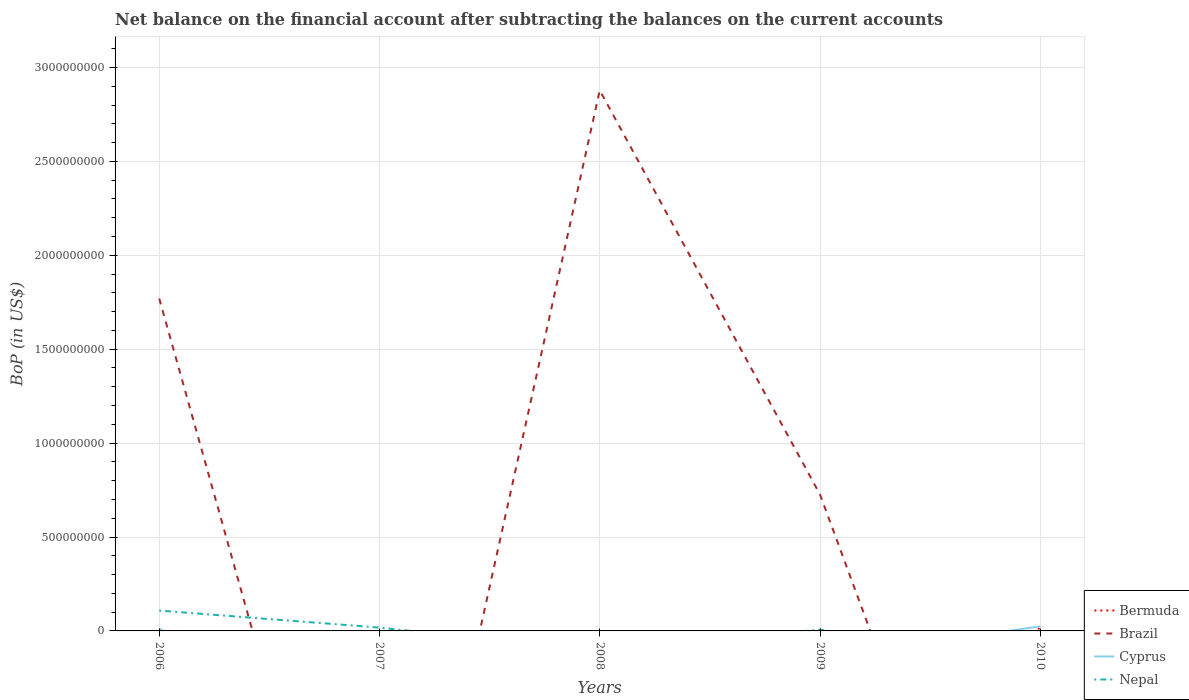Does the line corresponding to Bermuda intersect with the line corresponding to Nepal?
Your answer should be compact. Yes. Across all years, what is the maximum Balance of Payments in Nepal?
Keep it short and to the point. 0. What is the total Balance of Payments in Nepal in the graph?
Offer a terse response. 1.07e+07. What is the difference between the highest and the second highest Balance of Payments in Nepal?
Provide a succinct answer. 1.08e+08. How many lines are there?
Provide a succinct answer. 4. How many years are there in the graph?
Keep it short and to the point. 5. Are the values on the major ticks of Y-axis written in scientific E-notation?
Your answer should be very brief. No. Where does the legend appear in the graph?
Your answer should be very brief. Bottom right. How are the legend labels stacked?
Offer a very short reply. Vertical. What is the title of the graph?
Your answer should be very brief. Net balance on the financial account after subtracting the balances on the current accounts. Does "Kuwait" appear as one of the legend labels in the graph?
Your answer should be very brief. No. What is the label or title of the X-axis?
Your answer should be very brief. Years. What is the label or title of the Y-axis?
Offer a very short reply. BoP (in US$). What is the BoP (in US$) of Brazil in 2006?
Provide a short and direct response. 1.77e+09. What is the BoP (in US$) of Cyprus in 2006?
Offer a terse response. 1.33e+07. What is the BoP (in US$) in Nepal in 2006?
Give a very brief answer. 1.08e+08. What is the BoP (in US$) in Bermuda in 2007?
Your response must be concise. 0. What is the BoP (in US$) in Nepal in 2007?
Provide a short and direct response. 1.77e+07. What is the BoP (in US$) of Bermuda in 2008?
Provide a short and direct response. 0. What is the BoP (in US$) of Brazil in 2008?
Give a very brief answer. 2.88e+09. What is the BoP (in US$) of Cyprus in 2008?
Ensure brevity in your answer.  0. What is the BoP (in US$) in Nepal in 2008?
Offer a terse response. 0. What is the BoP (in US$) of Bermuda in 2009?
Provide a succinct answer. 0. What is the BoP (in US$) in Brazil in 2009?
Make the answer very short. 7.26e+08. What is the BoP (in US$) in Cyprus in 2009?
Provide a succinct answer. 0. What is the BoP (in US$) in Nepal in 2009?
Offer a terse response. 7.03e+06. What is the BoP (in US$) in Bermuda in 2010?
Offer a terse response. 1.80e+07. What is the BoP (in US$) of Brazil in 2010?
Make the answer very short. 0. What is the BoP (in US$) of Cyprus in 2010?
Offer a terse response. 2.44e+07. Across all years, what is the maximum BoP (in US$) of Bermuda?
Your response must be concise. 1.80e+07. Across all years, what is the maximum BoP (in US$) in Brazil?
Offer a terse response. 2.88e+09. Across all years, what is the maximum BoP (in US$) of Cyprus?
Provide a short and direct response. 2.44e+07. Across all years, what is the maximum BoP (in US$) of Nepal?
Offer a terse response. 1.08e+08. Across all years, what is the minimum BoP (in US$) of Bermuda?
Provide a short and direct response. 0. Across all years, what is the minimum BoP (in US$) in Brazil?
Offer a very short reply. 0. Across all years, what is the minimum BoP (in US$) of Cyprus?
Ensure brevity in your answer.  0. Across all years, what is the minimum BoP (in US$) in Nepal?
Keep it short and to the point. 0. What is the total BoP (in US$) of Bermuda in the graph?
Give a very brief answer. 1.80e+07. What is the total BoP (in US$) in Brazil in the graph?
Offer a very short reply. 5.37e+09. What is the total BoP (in US$) of Cyprus in the graph?
Provide a short and direct response. 3.78e+07. What is the total BoP (in US$) of Nepal in the graph?
Ensure brevity in your answer.  1.33e+08. What is the difference between the BoP (in US$) in Nepal in 2006 and that in 2007?
Give a very brief answer. 9.06e+07. What is the difference between the BoP (in US$) of Brazil in 2006 and that in 2008?
Provide a short and direct response. -1.11e+09. What is the difference between the BoP (in US$) of Brazil in 2006 and that in 2009?
Make the answer very short. 1.04e+09. What is the difference between the BoP (in US$) of Nepal in 2006 and that in 2009?
Your response must be concise. 1.01e+08. What is the difference between the BoP (in US$) in Cyprus in 2006 and that in 2010?
Your answer should be very brief. -1.11e+07. What is the difference between the BoP (in US$) in Nepal in 2007 and that in 2009?
Make the answer very short. 1.07e+07. What is the difference between the BoP (in US$) of Brazil in 2008 and that in 2009?
Offer a terse response. 2.15e+09. What is the difference between the BoP (in US$) in Brazil in 2006 and the BoP (in US$) in Nepal in 2007?
Make the answer very short. 1.75e+09. What is the difference between the BoP (in US$) of Cyprus in 2006 and the BoP (in US$) of Nepal in 2007?
Provide a succinct answer. -4.38e+06. What is the difference between the BoP (in US$) of Brazil in 2006 and the BoP (in US$) of Nepal in 2009?
Keep it short and to the point. 1.76e+09. What is the difference between the BoP (in US$) in Cyprus in 2006 and the BoP (in US$) in Nepal in 2009?
Provide a succinct answer. 6.31e+06. What is the difference between the BoP (in US$) of Brazil in 2006 and the BoP (in US$) of Cyprus in 2010?
Offer a terse response. 1.75e+09. What is the difference between the BoP (in US$) in Brazil in 2008 and the BoP (in US$) in Nepal in 2009?
Provide a short and direct response. 2.87e+09. What is the difference between the BoP (in US$) in Brazil in 2008 and the BoP (in US$) in Cyprus in 2010?
Ensure brevity in your answer.  2.85e+09. What is the difference between the BoP (in US$) in Brazil in 2009 and the BoP (in US$) in Cyprus in 2010?
Provide a short and direct response. 7.02e+08. What is the average BoP (in US$) in Bermuda per year?
Offer a very short reply. 3.61e+06. What is the average BoP (in US$) in Brazil per year?
Offer a terse response. 1.07e+09. What is the average BoP (in US$) of Cyprus per year?
Offer a very short reply. 7.55e+06. What is the average BoP (in US$) of Nepal per year?
Your answer should be compact. 2.66e+07. In the year 2006, what is the difference between the BoP (in US$) of Brazil and BoP (in US$) of Cyprus?
Keep it short and to the point. 1.76e+09. In the year 2006, what is the difference between the BoP (in US$) in Brazil and BoP (in US$) in Nepal?
Your answer should be compact. 1.66e+09. In the year 2006, what is the difference between the BoP (in US$) of Cyprus and BoP (in US$) of Nepal?
Give a very brief answer. -9.50e+07. In the year 2009, what is the difference between the BoP (in US$) of Brazil and BoP (in US$) of Nepal?
Offer a very short reply. 7.19e+08. In the year 2010, what is the difference between the BoP (in US$) of Bermuda and BoP (in US$) of Cyprus?
Make the answer very short. -6.38e+06. What is the ratio of the BoP (in US$) of Nepal in 2006 to that in 2007?
Give a very brief answer. 6.11. What is the ratio of the BoP (in US$) of Brazil in 2006 to that in 2008?
Keep it short and to the point. 0.61. What is the ratio of the BoP (in US$) of Brazil in 2006 to that in 2009?
Provide a succinct answer. 2.44. What is the ratio of the BoP (in US$) in Nepal in 2006 to that in 2009?
Your response must be concise. 15.41. What is the ratio of the BoP (in US$) of Cyprus in 2006 to that in 2010?
Offer a terse response. 0.55. What is the ratio of the BoP (in US$) of Nepal in 2007 to that in 2009?
Ensure brevity in your answer.  2.52. What is the ratio of the BoP (in US$) in Brazil in 2008 to that in 2009?
Offer a very short reply. 3.96. What is the difference between the highest and the second highest BoP (in US$) of Brazil?
Give a very brief answer. 1.11e+09. What is the difference between the highest and the second highest BoP (in US$) of Nepal?
Ensure brevity in your answer.  9.06e+07. What is the difference between the highest and the lowest BoP (in US$) in Bermuda?
Your answer should be compact. 1.80e+07. What is the difference between the highest and the lowest BoP (in US$) in Brazil?
Your answer should be compact. 2.88e+09. What is the difference between the highest and the lowest BoP (in US$) in Cyprus?
Your answer should be very brief. 2.44e+07. What is the difference between the highest and the lowest BoP (in US$) in Nepal?
Provide a short and direct response. 1.08e+08. 